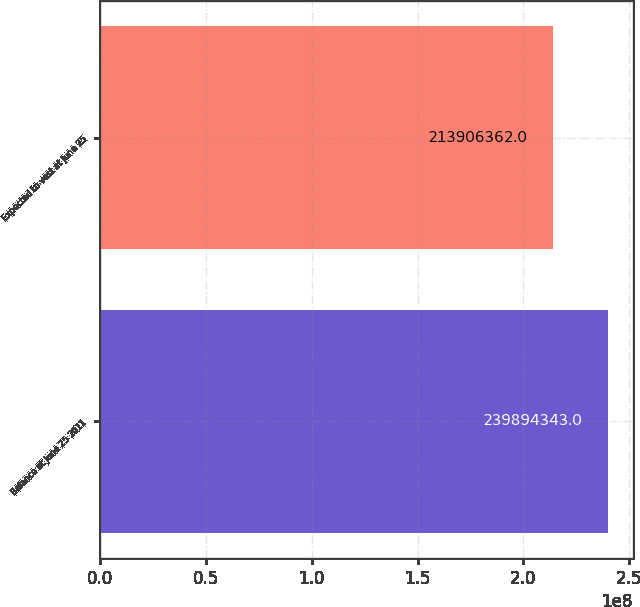Convert chart to OTSL. <chart><loc_0><loc_0><loc_500><loc_500><bar_chart><fcel>Balance at June 25 2011<fcel>Expected to vest at June 25<nl><fcel>2.39894e+08<fcel>2.13906e+08<nl></chart> 